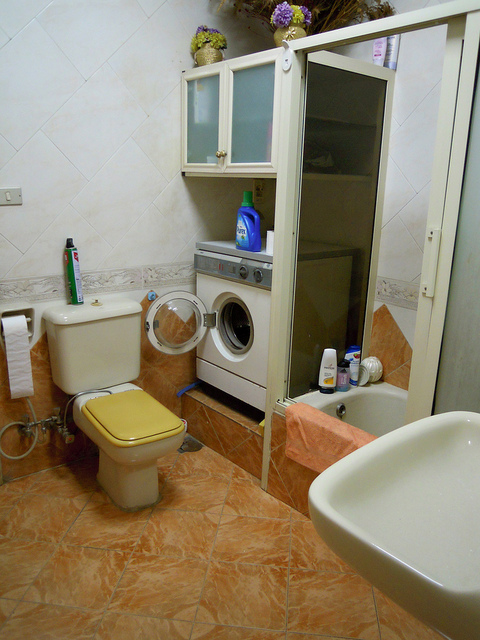<image>Is this bathroom compliant with local building codes? I am not sure if this bathroom is compliant with local building codes. Is this bathroom compliant with local building codes? I don't know if this bathroom is compliant with local building codes. It seems to be a mix of both compliant and non-compliant aspects. 